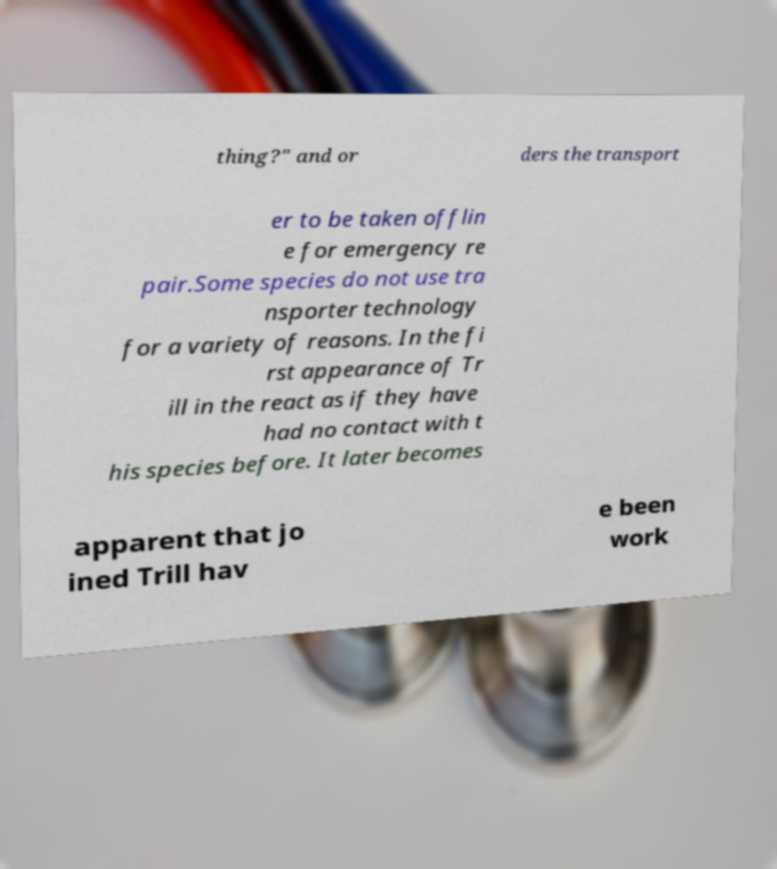Could you assist in decoding the text presented in this image and type it out clearly? thing?" and or ders the transport er to be taken offlin e for emergency re pair.Some species do not use tra nsporter technology for a variety of reasons. In the fi rst appearance of Tr ill in the react as if they have had no contact with t his species before. It later becomes apparent that jo ined Trill hav e been work 